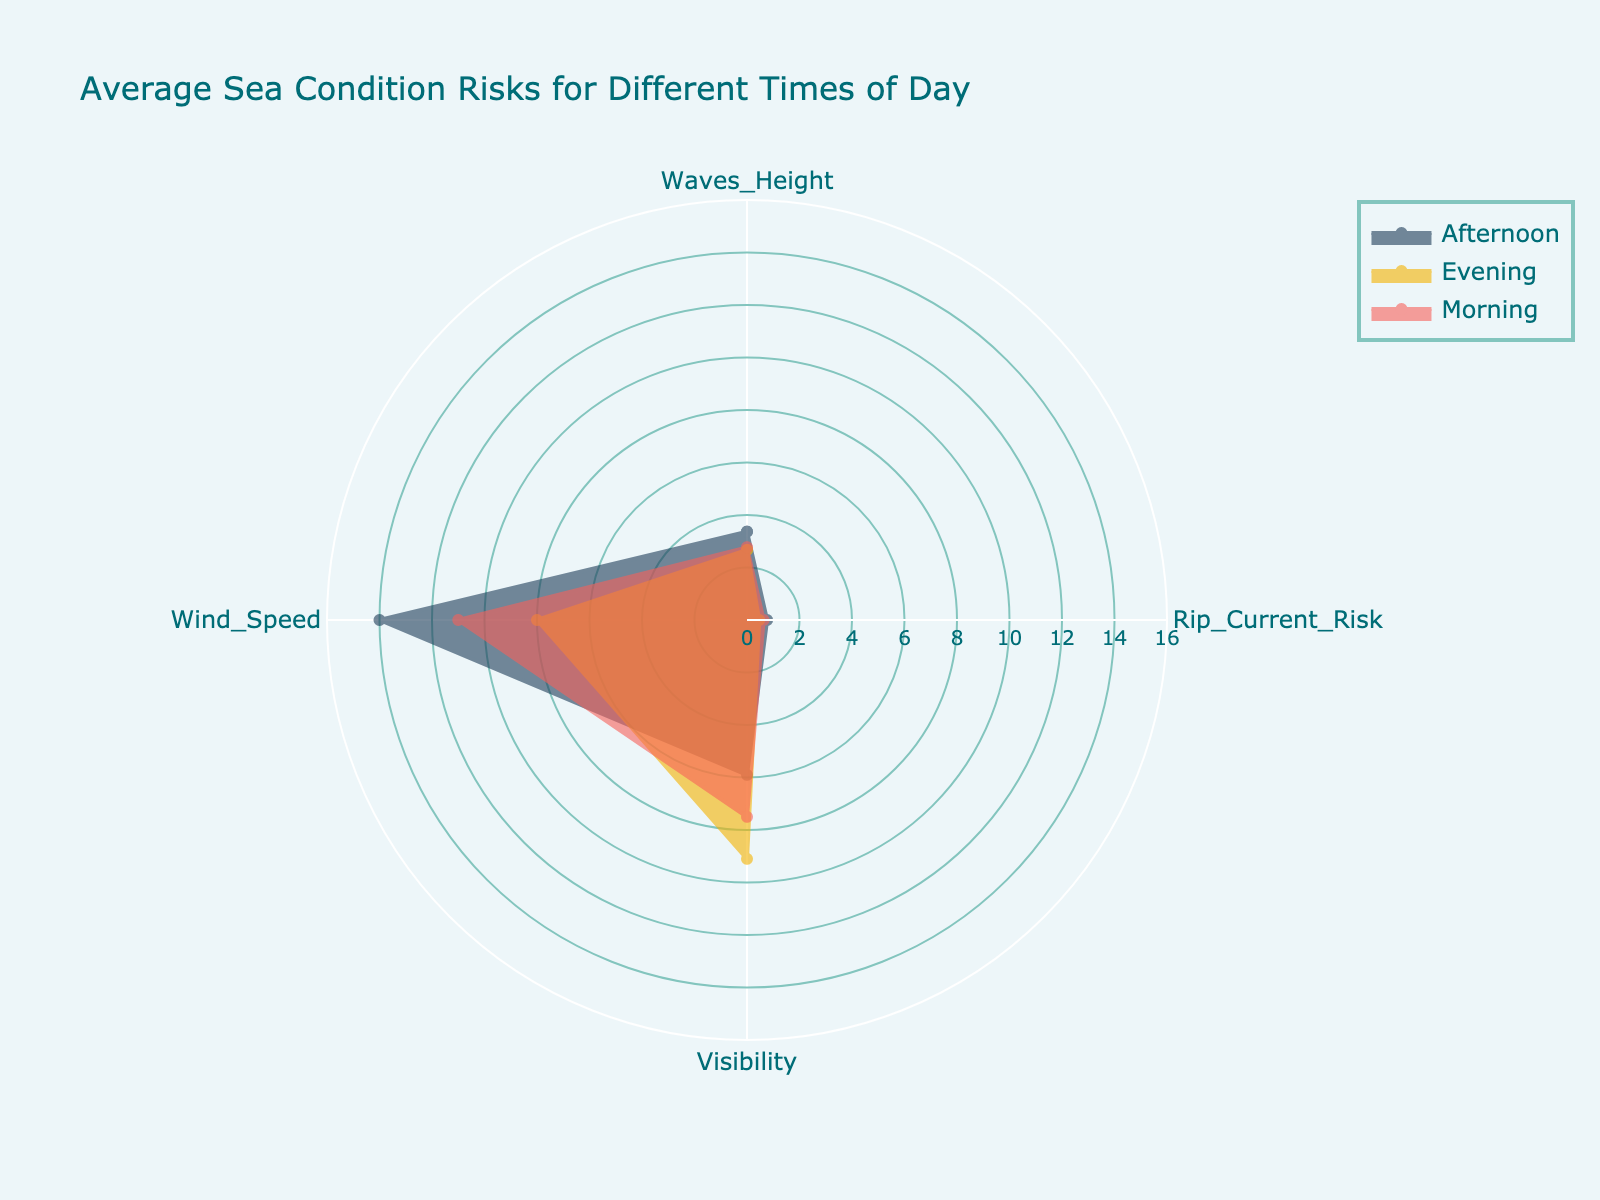What's the title of the radar chart? The radar chart title is typically displayed prominently at the top. In this case, the title should be "Average Sea Condition Risks for Different Times of Day."
Answer: Average Sea Condition Risks for Different Times of Day Which time of day has the highest average wave height? To determine the highest average wave height, compare the values in the "Waves_Height" category for each time of day. Afternoon has the highest average "Waves_Height" value.
Answer: Afternoon Which has the lowest average visibility, and what is its value? To find the lowest average visibility, compare the values in the "Visibility" category for each time of day. Afternoon has the lowest value with an average of 5.9.
Answer: Afternoon, 5.9 What’s the difference in average wind speed between Morning and Evening? To calculate the difference, find the average wind speeds for Morning and Evening and subtract the Evening value from the Morning value. Morning averages 11, and Evening averages 8, so the difference is 3.
Answer: 3 Which time of day generally has the lowest rip current risk? Compare the "Rip_Current_Risk" values for each of the three times of day. Evening has the lowest average rip current risk.
Answer: Evening How many categories are used to assess sea condition risks on the radar chart? Identify the number of different categories (axes) used in the radar chart. Inspecting the chart shows there are four categories: "Waves_Height," "Rip_Current_Risk," "Visibility," and "Wind_Speed."
Answer: Four In which category is the afternoon value the highest compared to other times of the day? Look at the values in each category and compare them for Afternoon against Morning and Evening. The "Waves_Height" category has the highest value for Afternoon.
Answer: Waves_Height Which time of day has the most consistent (least variation) values across all categories? A consistent time of day will have similar values across all categories. Evening has the most consistent values since there is less variation between its minimum and maximum values.
Answer: Evening Considering all categories, which time of day seems potentially the riskiest overall? Assess each time of day across all categories to see which one has the highest set of average values. Afternoon consistently features higher values in categories related to risk, indicating it's potentially the riskiest time.
Answer: Afternoon 